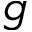Convert formula to latex. <formula><loc_0><loc_0><loc_500><loc_500>g</formula> 